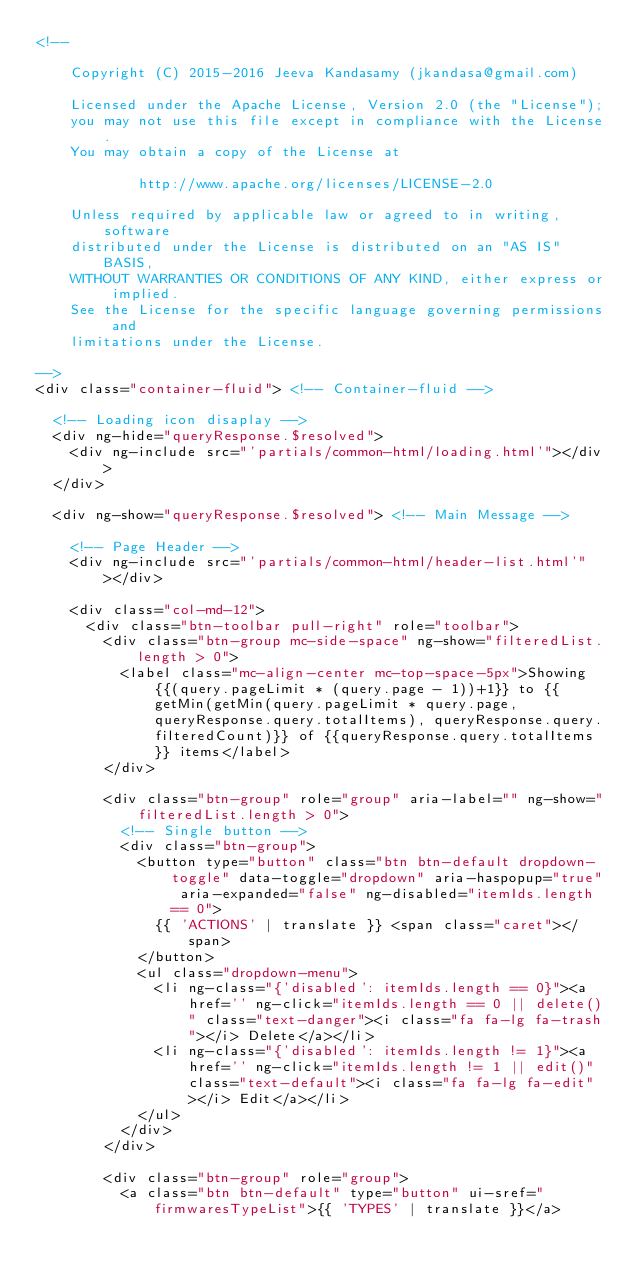Convert code to text. <code><loc_0><loc_0><loc_500><loc_500><_HTML_><!--

    Copyright (C) 2015-2016 Jeeva Kandasamy (jkandasa@gmail.com)

    Licensed under the Apache License, Version 2.0 (the "License");
    you may not use this file except in compliance with the License.
    You may obtain a copy of the License at

            http://www.apache.org/licenses/LICENSE-2.0

    Unless required by applicable law or agreed to in writing, software
    distributed under the License is distributed on an "AS IS" BASIS,
    WITHOUT WARRANTIES OR CONDITIONS OF ANY KIND, either express or implied.
    See the License for the specific language governing permissions and
    limitations under the License.

-->
<div class="container-fluid"> <!-- Container-fluid -->

  <!-- Loading icon disaplay -->
  <div ng-hide="queryResponse.$resolved">
    <div ng-include src="'partials/common-html/loading.html'"></div>
  </div>

  <div ng-show="queryResponse.$resolved"> <!-- Main Message -->

    <!-- Page Header -->
    <div ng-include src="'partials/common-html/header-list.html'"></div>

    <div class="col-md-12">
      <div class="btn-toolbar pull-right" role="toolbar">
        <div class="btn-group mc-side-space" ng-show="filteredList.length > 0">
          <label class="mc-align-center mc-top-space-5px">Showing {{(query.pageLimit * (query.page - 1))+1}} to {{getMin(getMin(query.pageLimit * query.page, queryResponse.query.totalItems), queryResponse.query.filteredCount)}} of {{queryResponse.query.totalItems}} items</label>
        </div>

        <div class="btn-group" role="group" aria-label="" ng-show="filteredList.length > 0">
          <!-- Single button -->
          <div class="btn-group">
            <button type="button" class="btn btn-default dropdown-toggle" data-toggle="dropdown" aria-haspopup="true" aria-expanded="false" ng-disabled="itemIds.length == 0">
              {{ 'ACTIONS' | translate }} <span class="caret"></span>
            </button>
            <ul class="dropdown-menu">
              <li ng-class="{'disabled': itemIds.length == 0}"><a href='' ng-click="itemIds.length == 0 || delete()" class="text-danger"><i class="fa fa-lg fa-trash"></i> Delete</a></li>
              <li ng-class="{'disabled': itemIds.length != 1}"><a href='' ng-click="itemIds.length != 1 || edit()" class="text-default"><i class="fa fa-lg fa-edit"></i> Edit</a></li>
            </ul>
          </div>
        </div>

        <div class="btn-group" role="group">
          <a class="btn btn-default" type="button" ui-sref="firmwaresTypeList">{{ 'TYPES' | translate }}</a></code> 